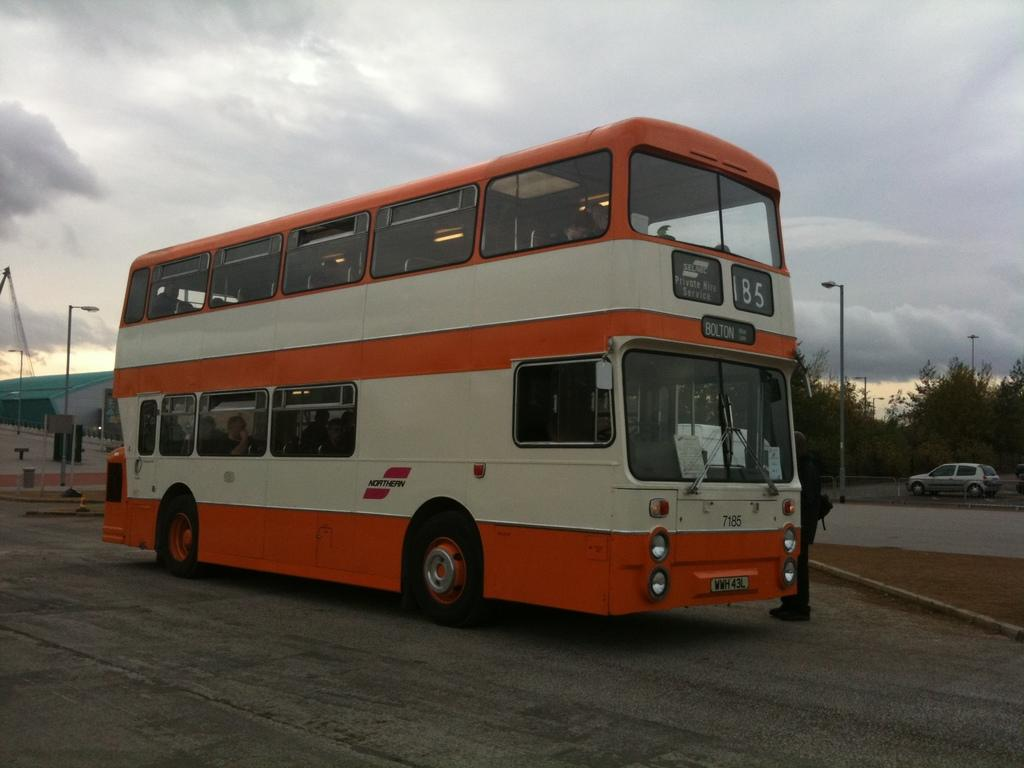What type of vehicle is on the road in the image? There is a bus on the road in the image. Who or what is inside the bus? There are people inside the bus. What other vehicles can be seen in the image? There is a car in the background of the image. What structures are visible in the background of the image? There are light poles, trees, and a building in the background of the image. What else can be seen in the background of the image? There are some objects and the sky in the background of the image. What is the condition of the sky in the image? The sky is visible in the background of the image, and there are clouds in the sky. What type of force is being applied to the stage in the image? There is no stage present in the image, so no force is being applied to it. 